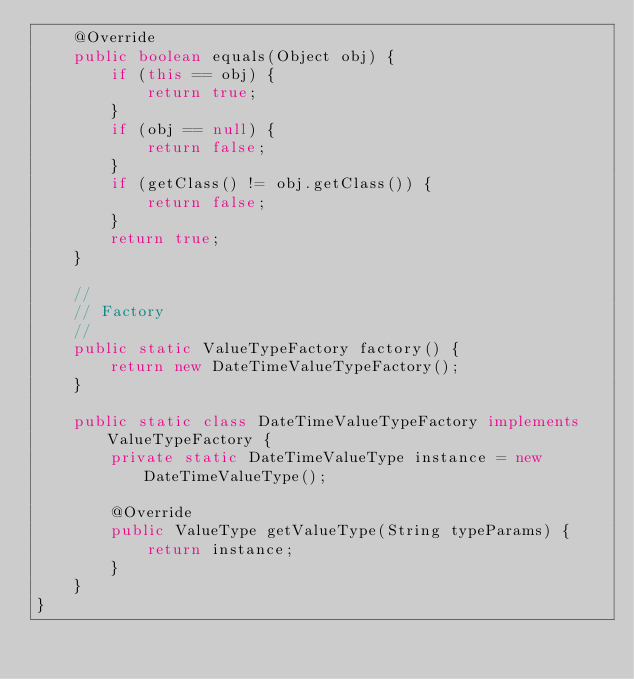Convert code to text. <code><loc_0><loc_0><loc_500><loc_500><_Java_>    @Override
    public boolean equals(Object obj) {
        if (this == obj) {
            return true;
        }
        if (obj == null) {
            return false;
        }
        if (getClass() != obj.getClass()) {
            return false;
        }
        return true;
    }

    //
    // Factory
    //
    public static ValueTypeFactory factory() {
        return new DateTimeValueTypeFactory();
    }

    public static class DateTimeValueTypeFactory implements ValueTypeFactory {
        private static DateTimeValueType instance = new DateTimeValueType();

        @Override
        public ValueType getValueType(String typeParams) {
            return instance;
        }
    }
}
</code> 